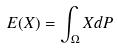<formula> <loc_0><loc_0><loc_500><loc_500>E ( X ) = \int _ { \Omega } X d P</formula> 